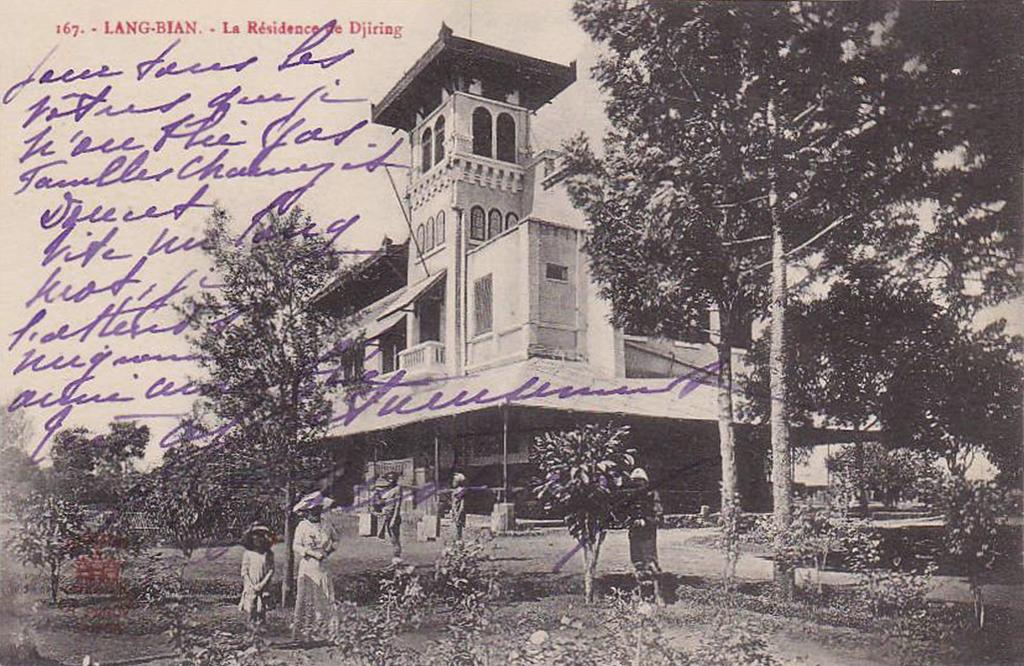What is the color scheme of the image? The image is black and white. What can be seen on the ground in the image? There are people standing on the ground in the image. What type of vegetation is present in the image? There are plants and trees in the image. What type of structure is visible in the image? There is a building in the image. What are the vertical structures visible in the image? Poles are visible in the image. What is visible in the background of the image? The sky is visible in the image, and clouds are present in the sky. How many degrees can be seen on the neck of the person in the image? There are no degrees visible on the neck of the person in the image, as it is a black and white photograph and not a medical illustration. How many beds are visible in the image? There are no beds present in the image; it features people, plants, trees, a building, poles, and the sky. 